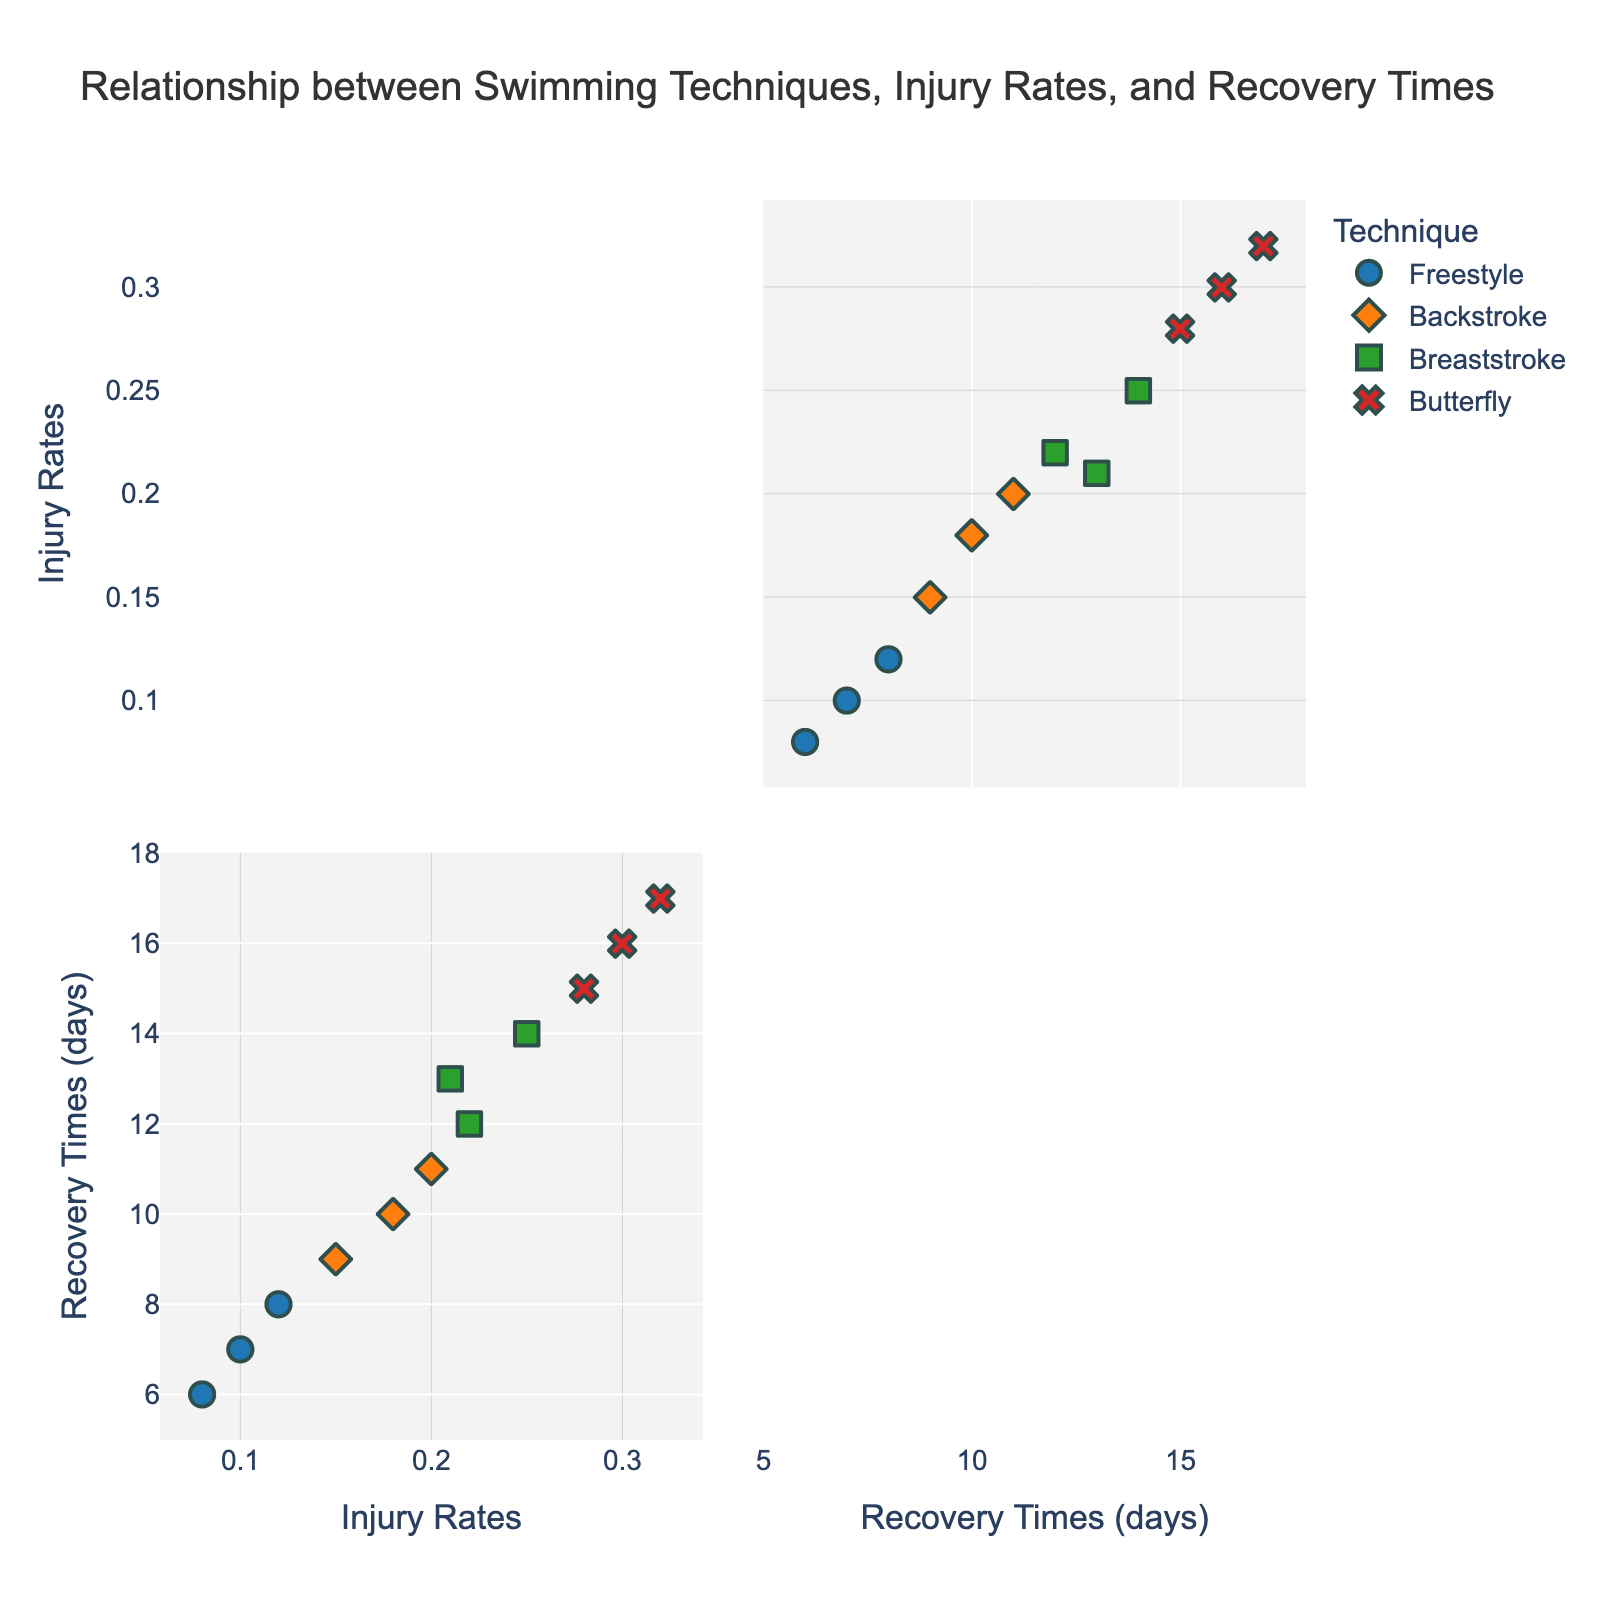What is the title of the scatter plot matrix? The title is located at the top of the figure and gives a summary of what the plot represents. In this case, the title helps the viewer understand that the plot shows the relationship between swimming techniques, injury rates, and recovery times.
Answer: Relationship between Swimming Techniques, Injury Rates, and Recovery Times How many different swimming techniques are represented in the plot? By looking at the distinct color and symbol combinations in the legend or within the plot, you can count the number of different swimming techniques. These are typically specified in a legend.
Answer: Four Which technique has the highest injury rate? Locate the data points on the x-axis for injury rates and identify the maximum value. Then, check the corresponding technique represented by the same color and symbol.
Answer: Butterfly What are the recovery times for Freestyle? Freestyle recovery times can be identified by the specific color or symbol assigned to Freestyle, and then checking the respective y-axis values.
Answer: 7, 8, 6 days What is the average injury rate for Breaststroke? Identify all data points related to Breaststroke, sum their injury rates, and divide by the number of data points. For Breaststroke, the injury rates are 0.22, 0.25, and 0.21. Sum these (0.22 + 0.25 + 0.21 = 0.68) and divide by 3.
Answer: 0.227 Which technique has the shortest average recovery time? You need to find the average recovery time for each technique by summing their recovery times and dividing by the number of instances. Then compare these average values across the techniques. For Freestyle (7 + 8 + 6)/3 = 7, Backstroke (10 + 9 + 11)/3 = 10, Breaststroke (12 + 14 + 13)/3 ≈ 13, and Butterfly (16 + 15 + 17)/3 ≈ 16.
Answer: Freestyle Which technique has the widest range of injury rates? The range of injury rates for each technique is determined by the difference between the maximum and minimum injury rates within that technique. For Freestyle (0.12 - 0.08 = 0.04), Backstroke (0.20 - 0.15 = 0.05), Breaststroke (0.25 - 0.21 = 0.04), and Butterfly (0.32 - 0.28 = 0.04).
Answer: Backstroke Are there any techniques that have overlapping recovery times? Compare the recovery time ranges for each technique. If any ranges overlap, then those techniques share similar recovery times. For Freestyle (6 to 8), Backstroke (9 to 11), Breaststroke (12 to 14), and Butterfly (15 to 17).
Answer: No Which technique has the most consistent injury rates? A consistent injury rate implies the smallest range between the highest and lowest values. Calculate the range for each technique and compare.
Answer: Freestyle 